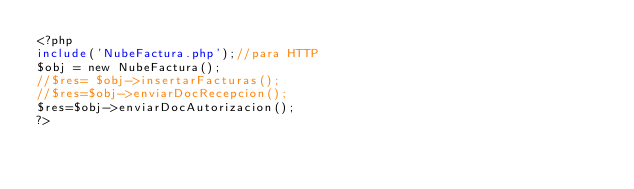Convert code to text. <code><loc_0><loc_0><loc_500><loc_500><_PHP_><?php
include('NubeFactura.php');//para HTTP
$obj = new NubeFactura();
//$res= $obj->insertarFacturas();
//$res=$obj->enviarDocRecepcion();
$res=$obj->enviarDocAutorizacion();
?></code> 